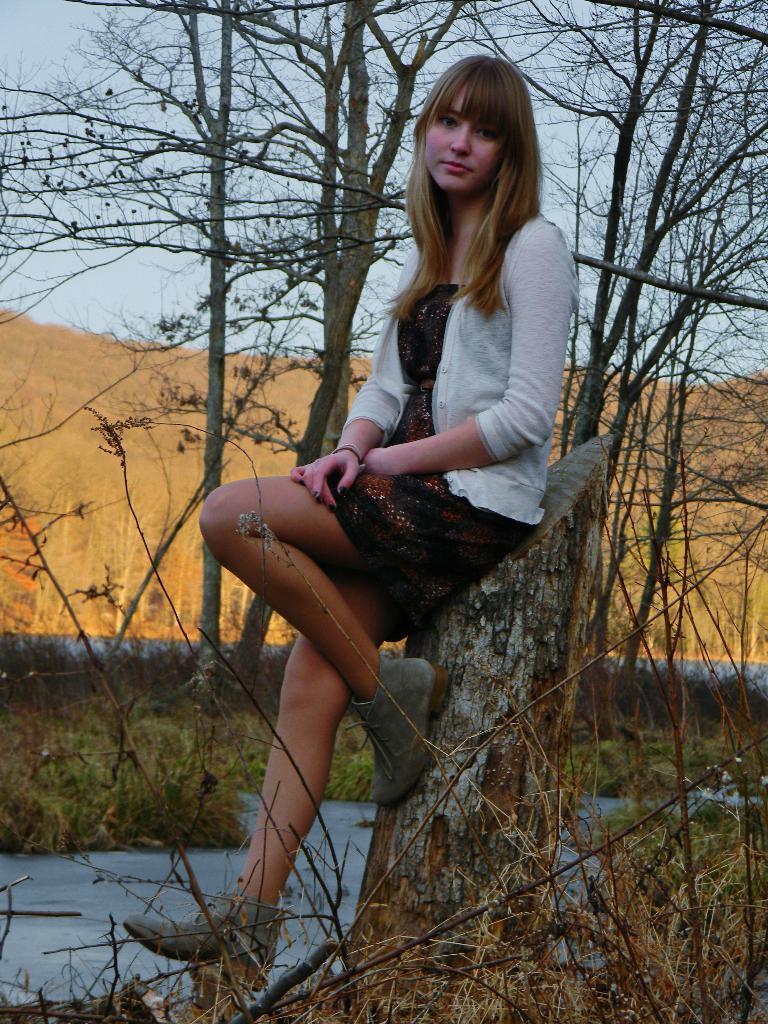Could you give a brief overview of what you see in this image? In this picture I can see a woman sitting on the trunk. I can see green grass. I can see trees. I can see clouds in the sky. 